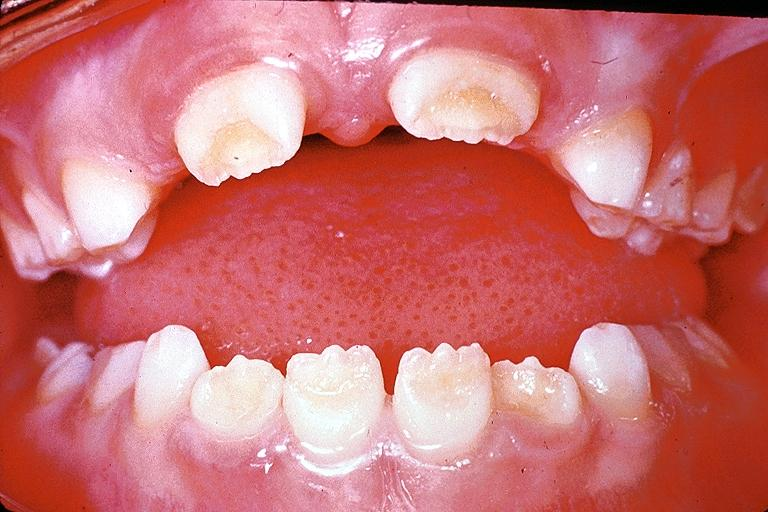what does this image show?
Answer the question using a single word or phrase. Amelogenesis imperfecta 